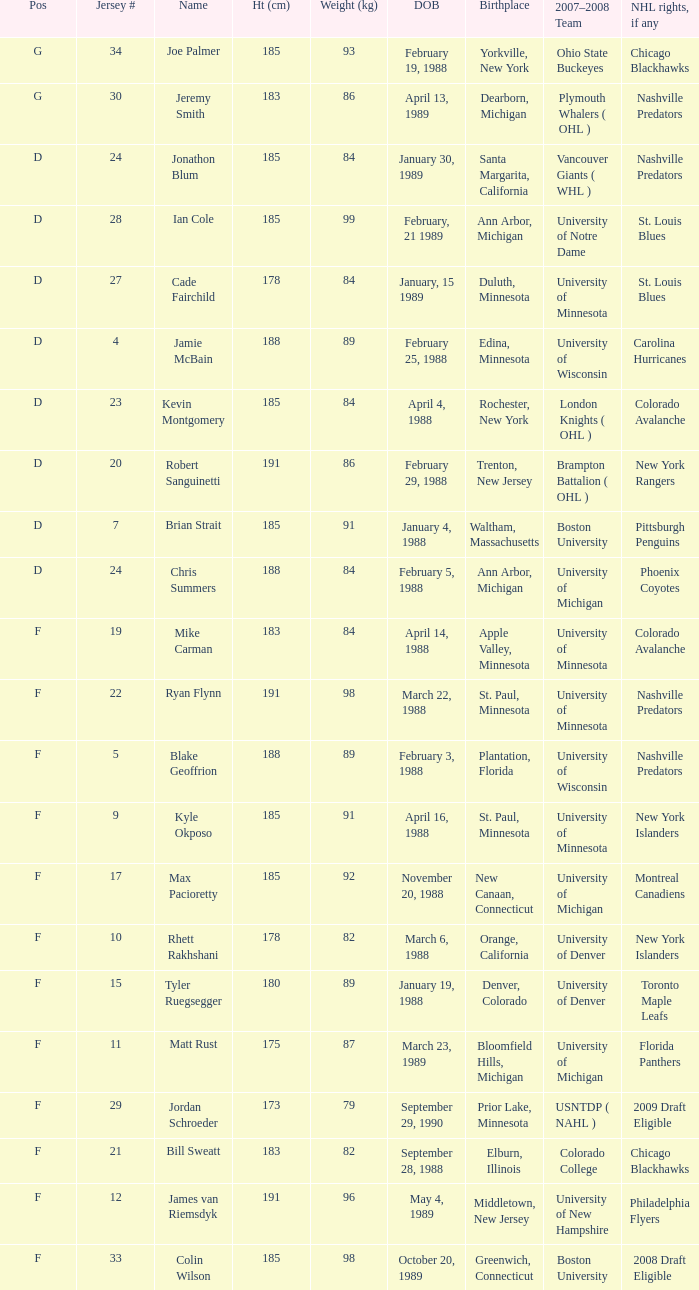Which Height (cm) has a Birthplace of new canaan, connecticut? 1.0. 